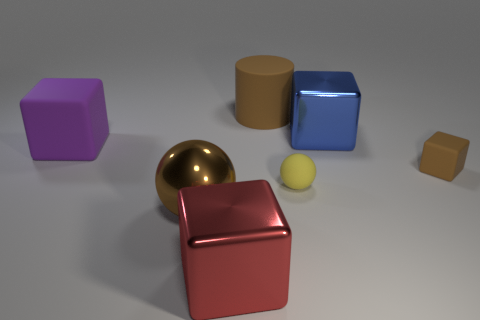Add 1 big blue cubes. How many objects exist? 8 Subtract all big purple rubber blocks. How many blocks are left? 3 Subtract 2 blocks. How many blocks are left? 2 Subtract all blue cubes. How many cubes are left? 3 Subtract all blocks. How many objects are left? 3 Subtract all red cubes. Subtract all brown cylinders. How many cubes are left? 3 Subtract all large brown spheres. Subtract all small brown objects. How many objects are left? 5 Add 3 big brown metal things. How many big brown metal things are left? 4 Add 2 red metallic objects. How many red metallic objects exist? 3 Subtract 0 yellow blocks. How many objects are left? 7 